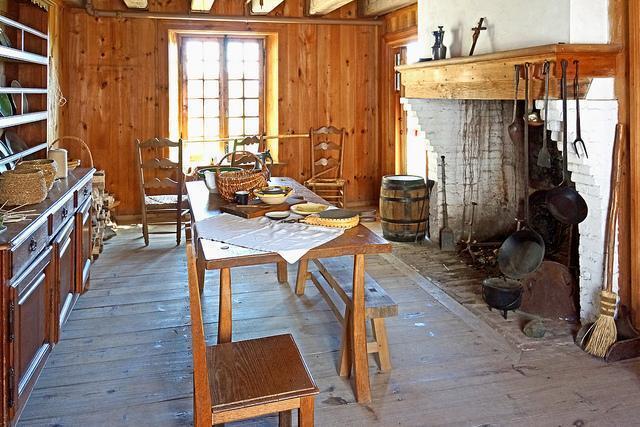What does the item hanging on the wall and closest to the broom look like?
Choose the correct response, then elucidate: 'Answer: answer
Rationale: rationale.'
Options: Cross, lips, straw, pitchfork. Answer: pitchfork.
Rationale: The item hanging on the wall close to the broom looks like a pitchfork. 